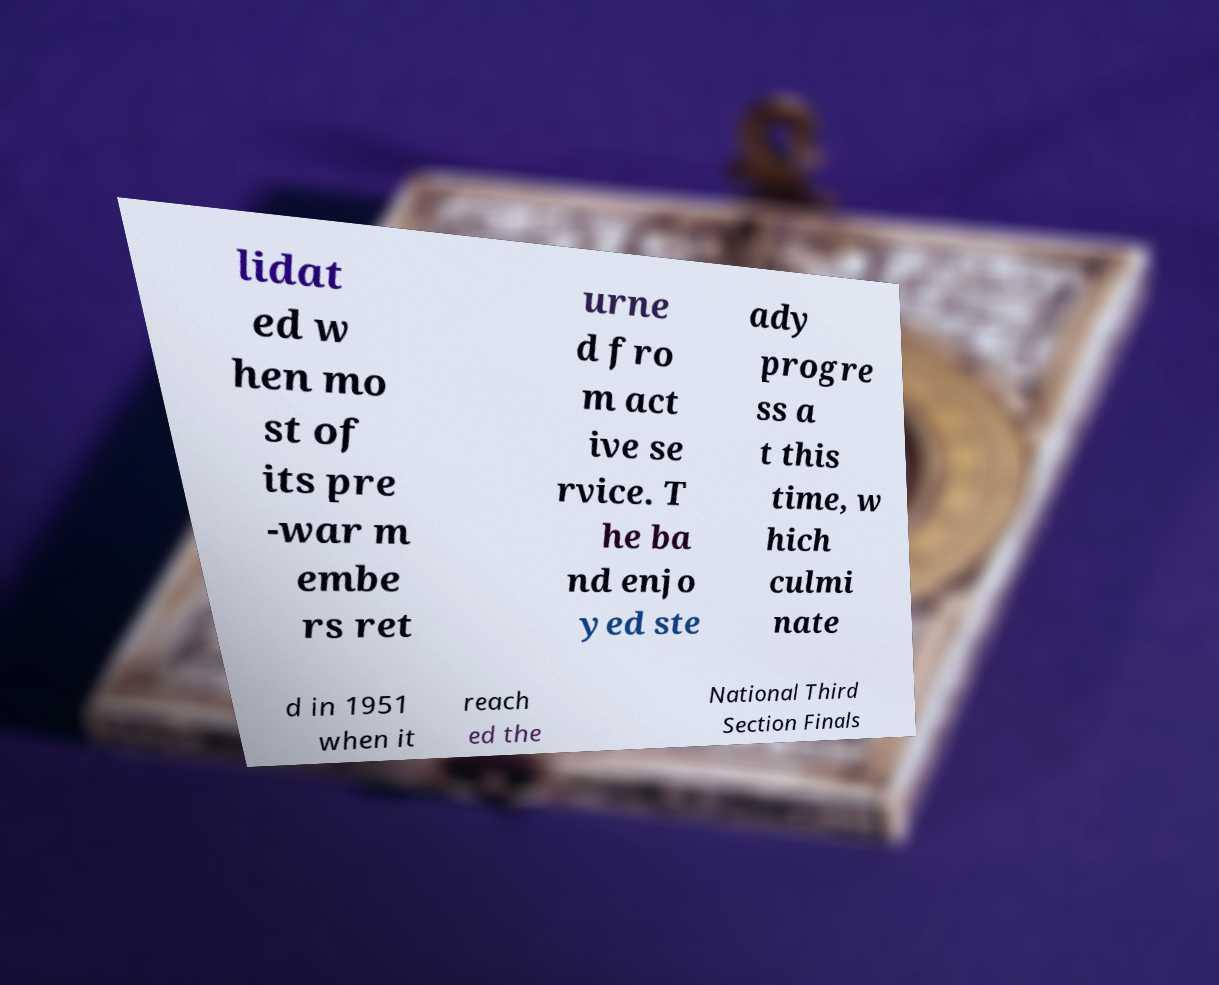For documentation purposes, I need the text within this image transcribed. Could you provide that? lidat ed w hen mo st of its pre -war m embe rs ret urne d fro m act ive se rvice. T he ba nd enjo yed ste ady progre ss a t this time, w hich culmi nate d in 1951 when it reach ed the National Third Section Finals 